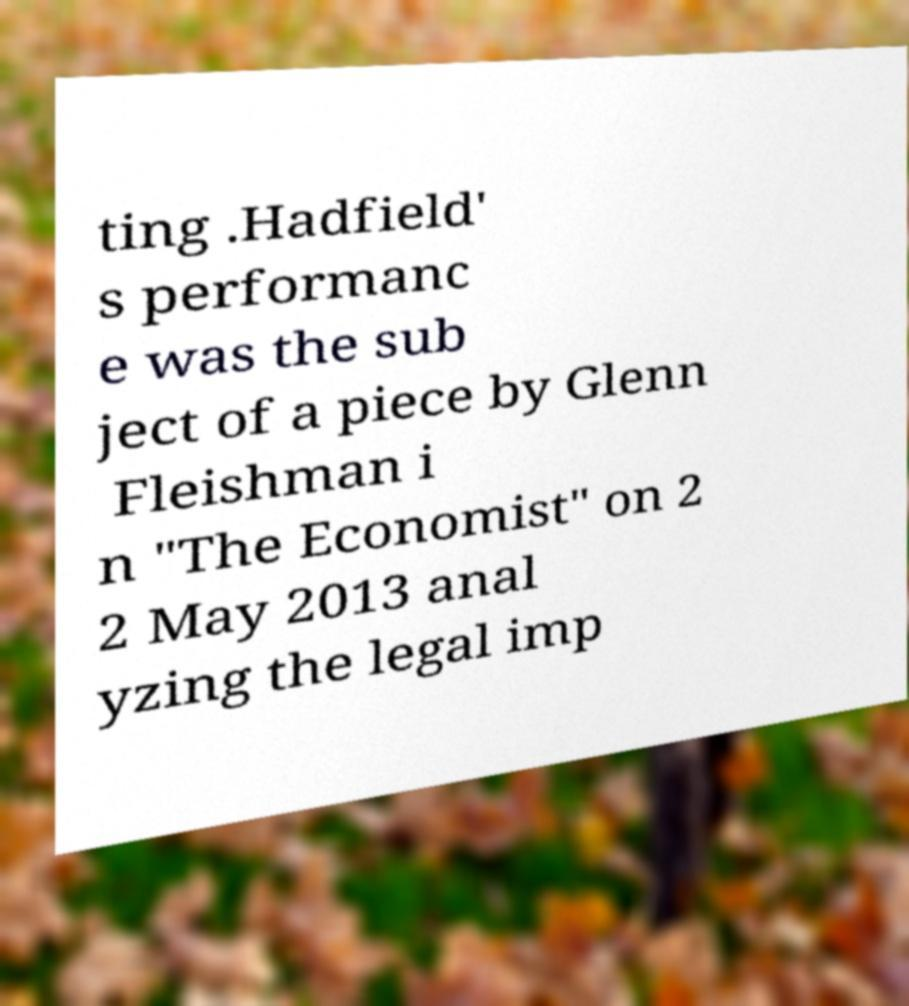I need the written content from this picture converted into text. Can you do that? ting .Hadfield' s performanc e was the sub ject of a piece by Glenn Fleishman i n "The Economist" on 2 2 May 2013 anal yzing the legal imp 